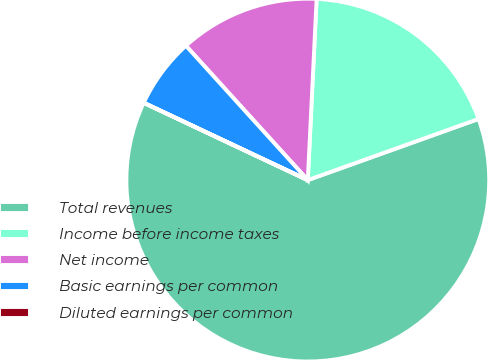Convert chart to OTSL. <chart><loc_0><loc_0><loc_500><loc_500><pie_chart><fcel>Total revenues<fcel>Income before income taxes<fcel>Net income<fcel>Basic earnings per common<fcel>Diluted earnings per common<nl><fcel>62.47%<fcel>18.75%<fcel>12.5%<fcel>6.26%<fcel>0.01%<nl></chart> 